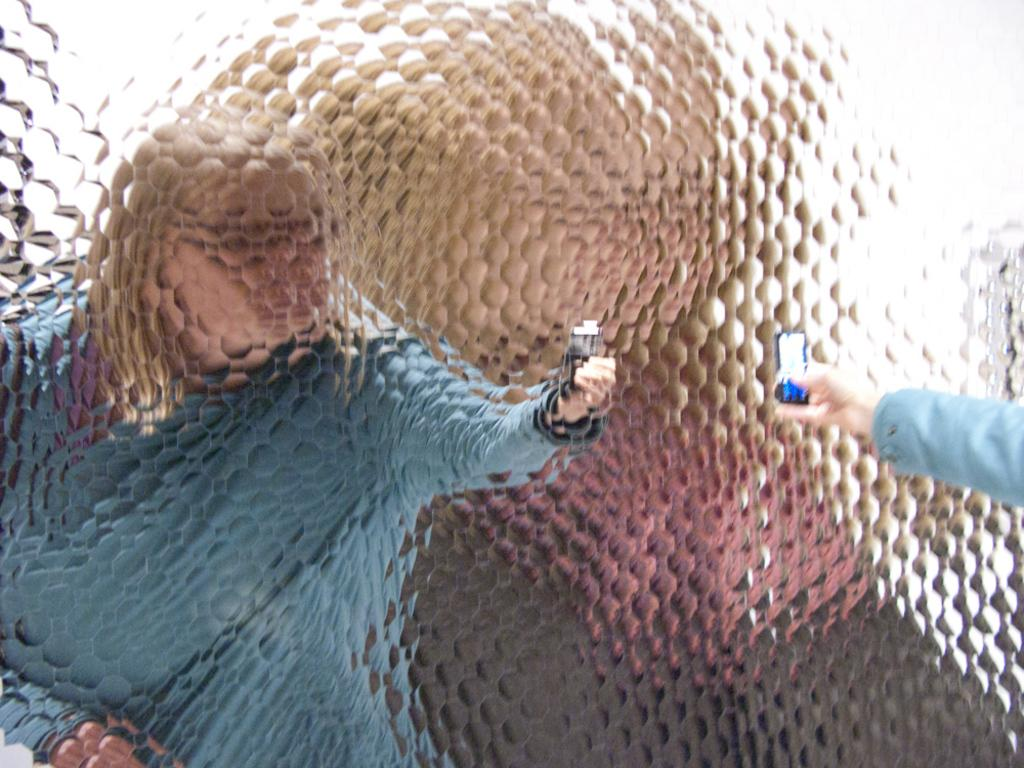What type of object is visible in the image? There is a glass object in the image. What can be seen in the reflection of the glass object? The reflection of a person can be seen in the glass object. What is the person in the reflection holding? The person in the reflection is holding a mobile. Can you hear the person's voice in the image? There is no audio component in the image, so it is not possible to hear the person's voice. 